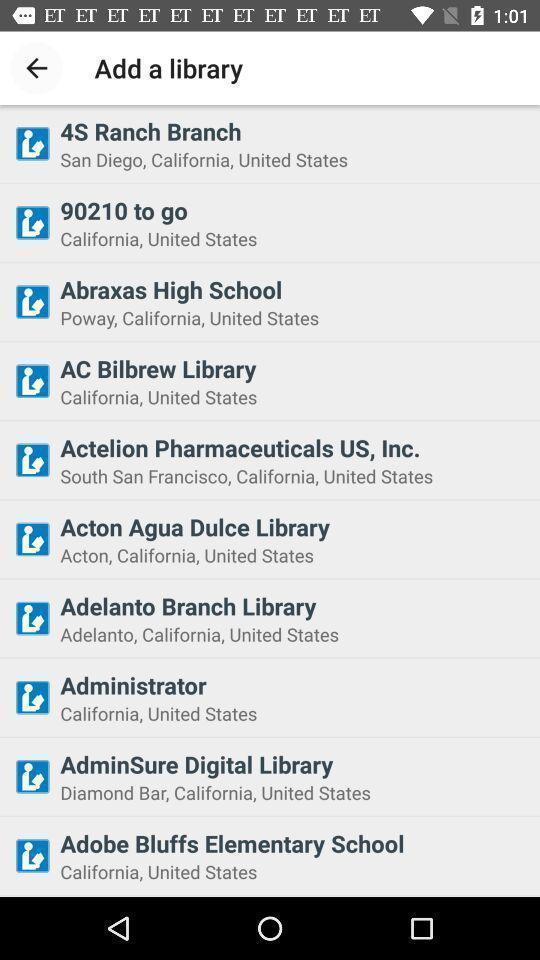Provide a description of this screenshot. Page displays different ebooks. 